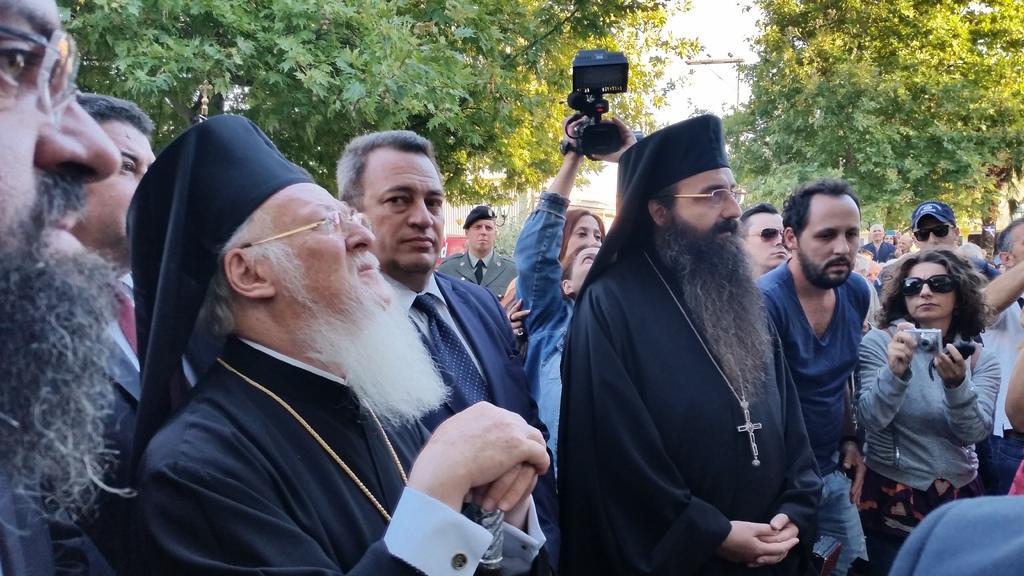Please provide a concise description of this image. This image is taken outdoors. In the background there are a few trees and there is a street light. In the middle of the image many people are standing on the road and a few are holding cameras in their hands to click pictures. 